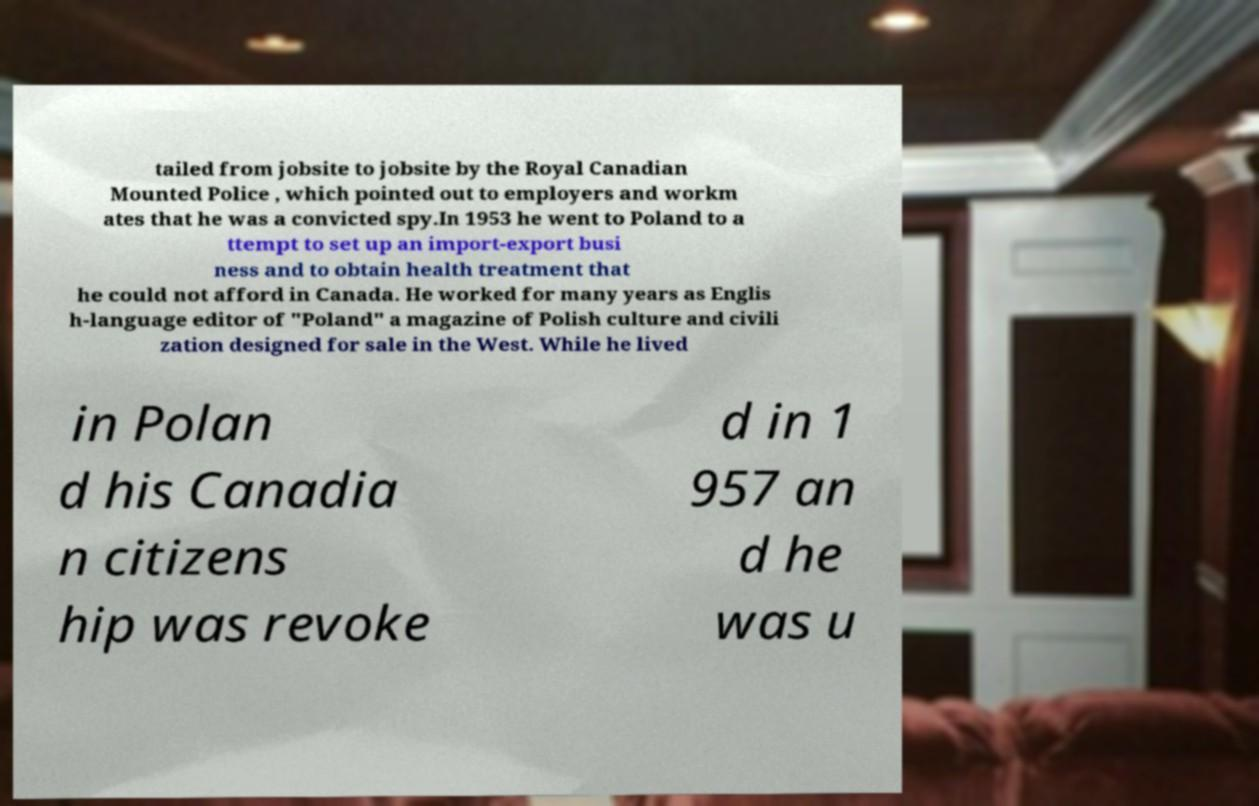Please read and relay the text visible in this image. What does it say? tailed from jobsite to jobsite by the Royal Canadian Mounted Police , which pointed out to employers and workm ates that he was a convicted spy.In 1953 he went to Poland to a ttempt to set up an import-export busi ness and to obtain health treatment that he could not afford in Canada. He worked for many years as Englis h-language editor of "Poland" a magazine of Polish culture and civili zation designed for sale in the West. While he lived in Polan d his Canadia n citizens hip was revoke d in 1 957 an d he was u 